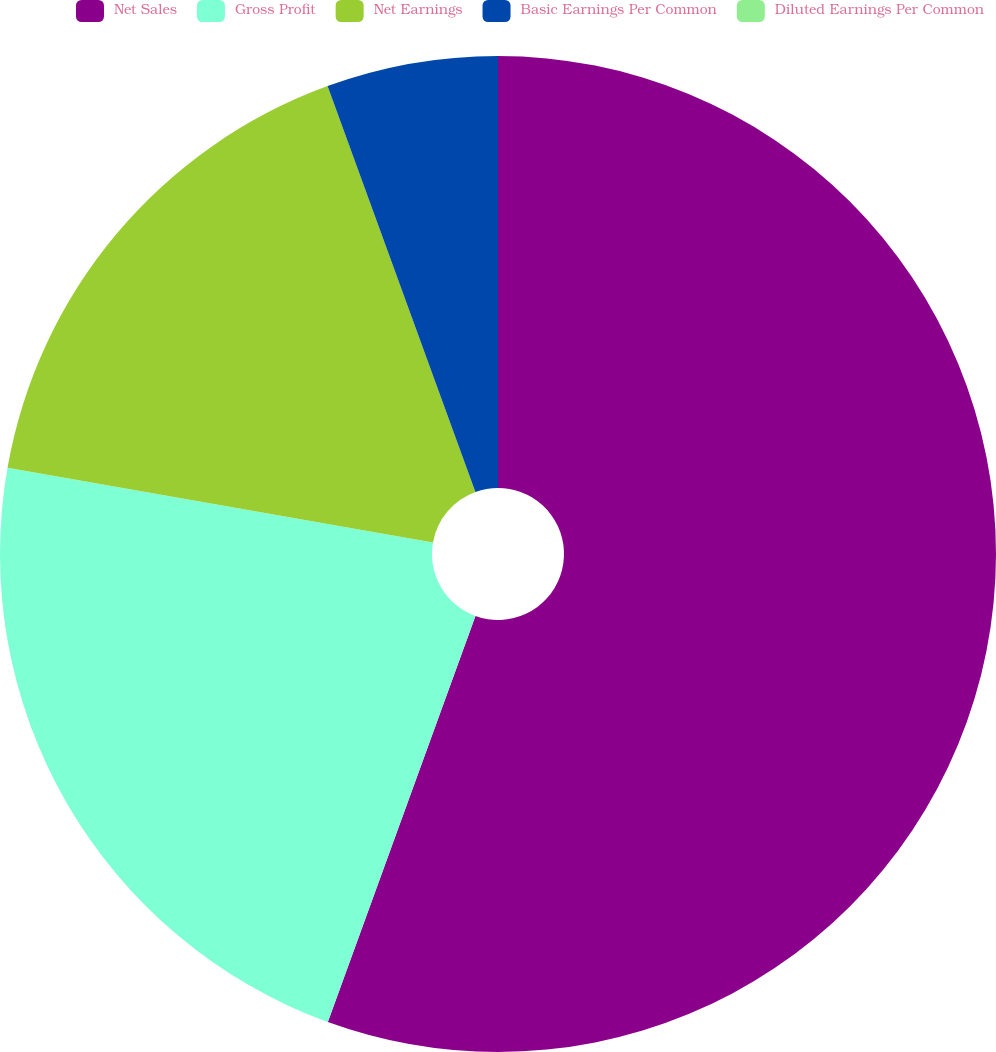Convert chart to OTSL. <chart><loc_0><loc_0><loc_500><loc_500><pie_chart><fcel>Net Sales<fcel>Gross Profit<fcel>Net Earnings<fcel>Basic Earnings Per Common<fcel>Diluted Earnings Per Common<nl><fcel>55.55%<fcel>22.22%<fcel>16.67%<fcel>5.56%<fcel>0.0%<nl></chart> 